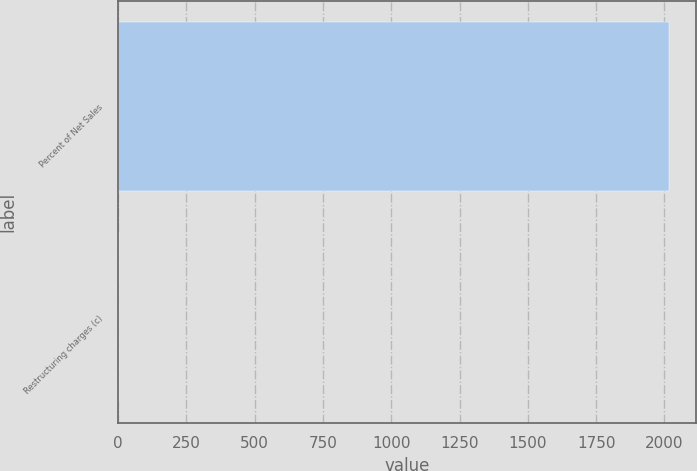<chart> <loc_0><loc_0><loc_500><loc_500><bar_chart><fcel>Percent of Net Sales<fcel>Restructuring charges (c)<nl><fcel>2016<fcel>1.3<nl></chart> 